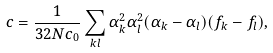Convert formula to latex. <formula><loc_0><loc_0><loc_500><loc_500>c = \frac { 1 } { 3 2 N c _ { 0 } } \sum _ { k l } \alpha _ { k } ^ { 2 } \alpha _ { l } ^ { 2 } ( \alpha _ { k } - \alpha _ { l } ) ( f _ { k } - f _ { l } ) ,</formula> 